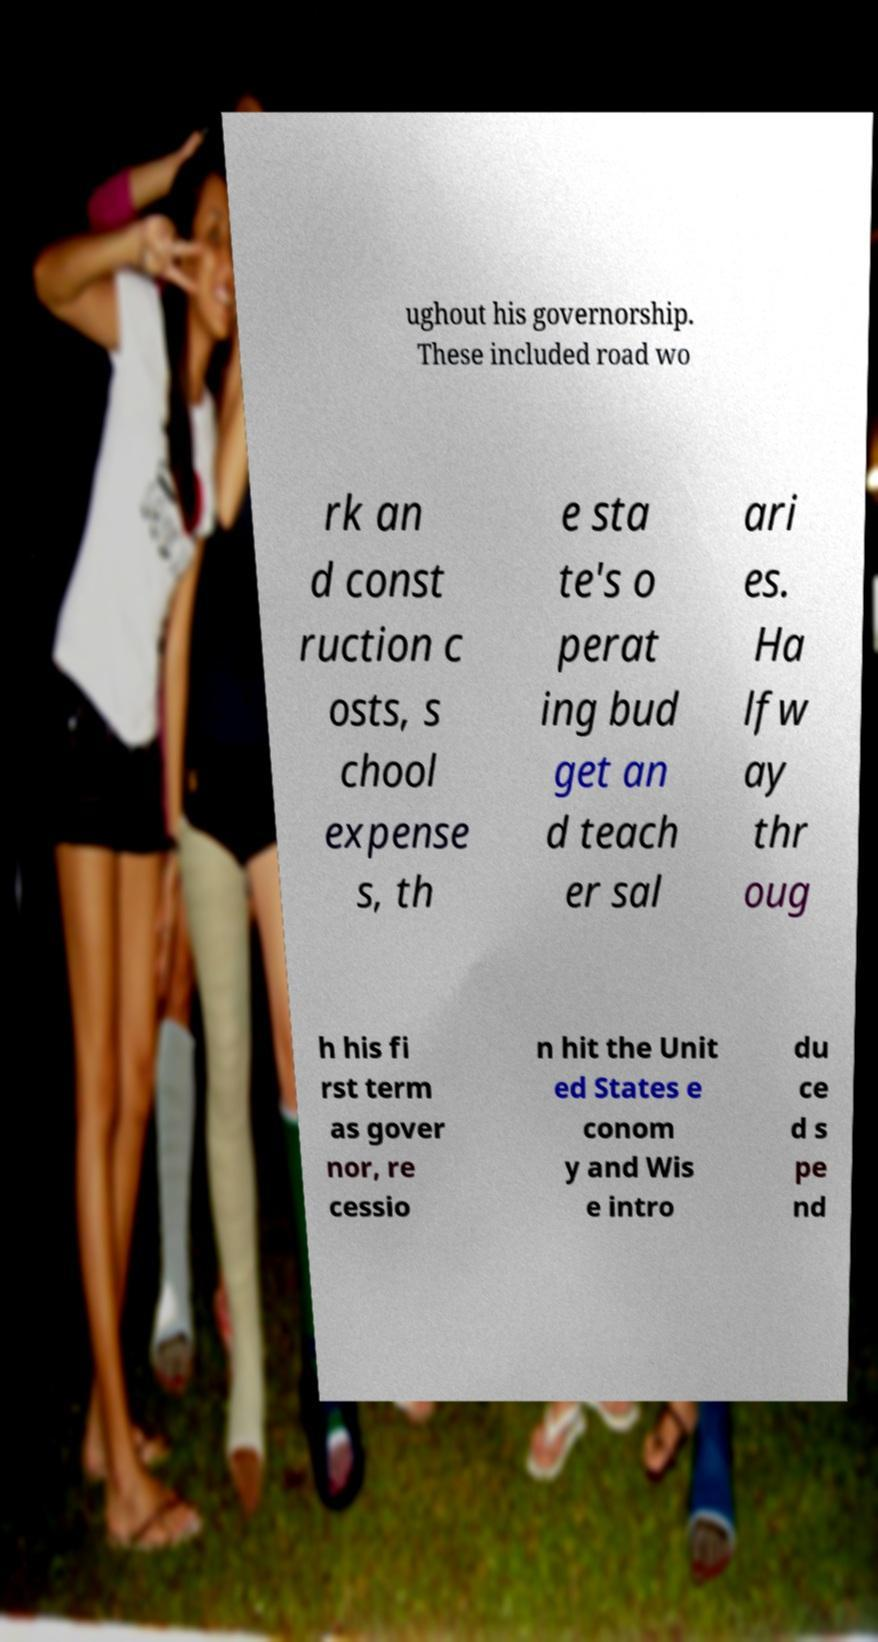Can you accurately transcribe the text from the provided image for me? ughout his governorship. These included road wo rk an d const ruction c osts, s chool expense s, th e sta te's o perat ing bud get an d teach er sal ari es. Ha lfw ay thr oug h his fi rst term as gover nor, re cessio n hit the Unit ed States e conom y and Wis e intro du ce d s pe nd 